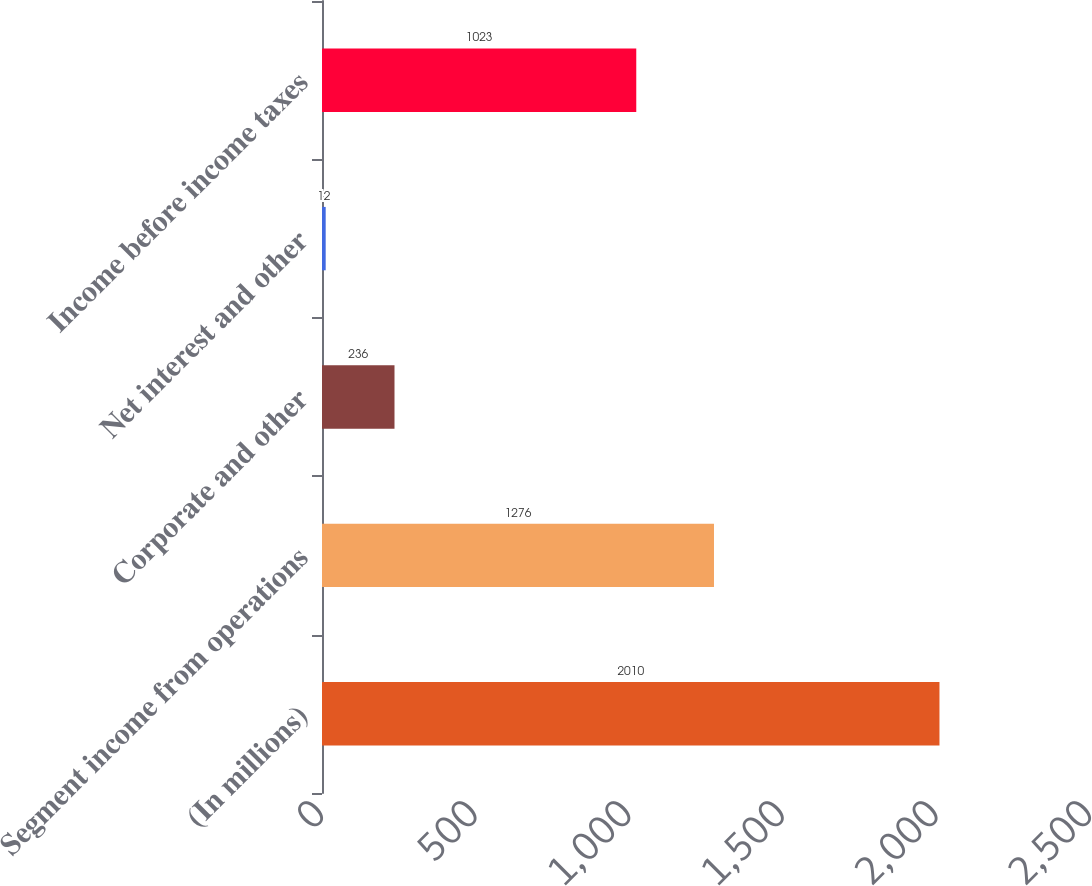Convert chart. <chart><loc_0><loc_0><loc_500><loc_500><bar_chart><fcel>(In millions)<fcel>Segment income from operations<fcel>Corporate and other<fcel>Net interest and other<fcel>Income before income taxes<nl><fcel>2010<fcel>1276<fcel>236<fcel>12<fcel>1023<nl></chart> 